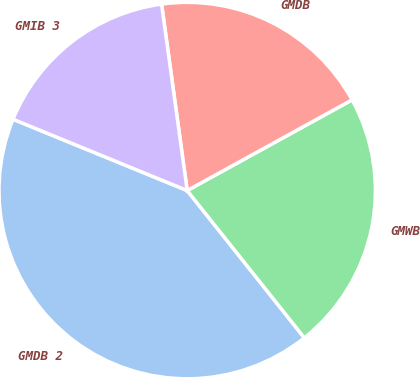Convert chart. <chart><loc_0><loc_0><loc_500><loc_500><pie_chart><fcel>GMDB 2<fcel>GMWB<fcel>GMDB<fcel>GMIB 3<nl><fcel>41.88%<fcel>22.31%<fcel>19.17%<fcel>16.64%<nl></chart> 